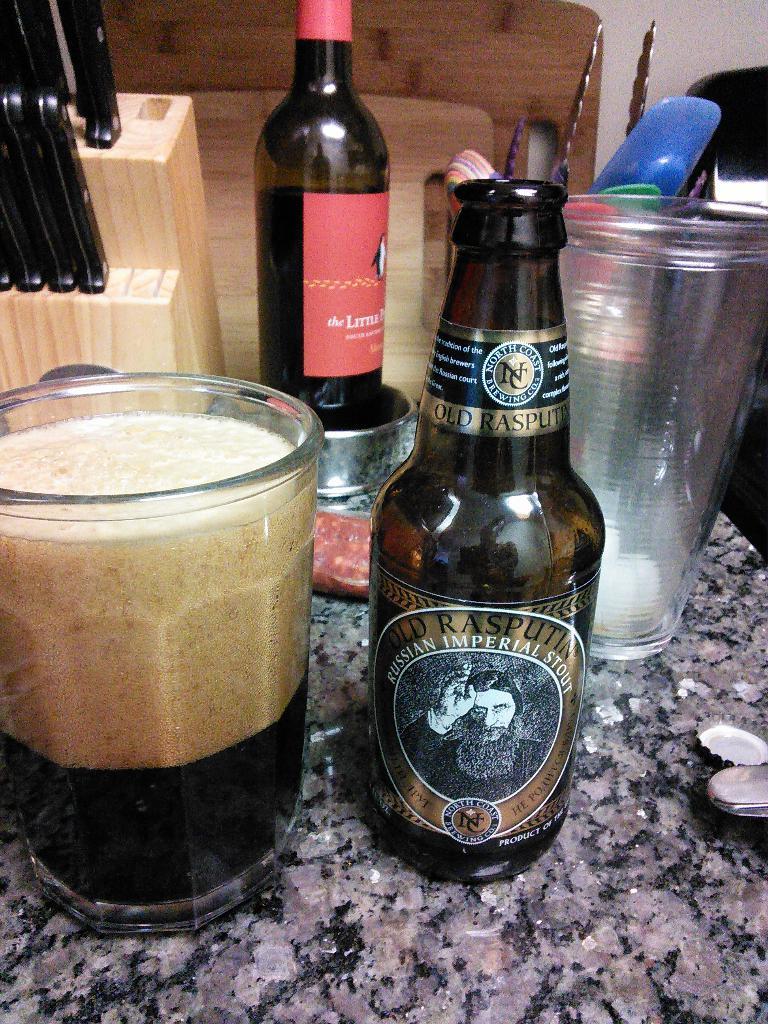What country is this beer from?
Make the answer very short. Russia. What kind of beer is this?
Your response must be concise. Old rasputin. 